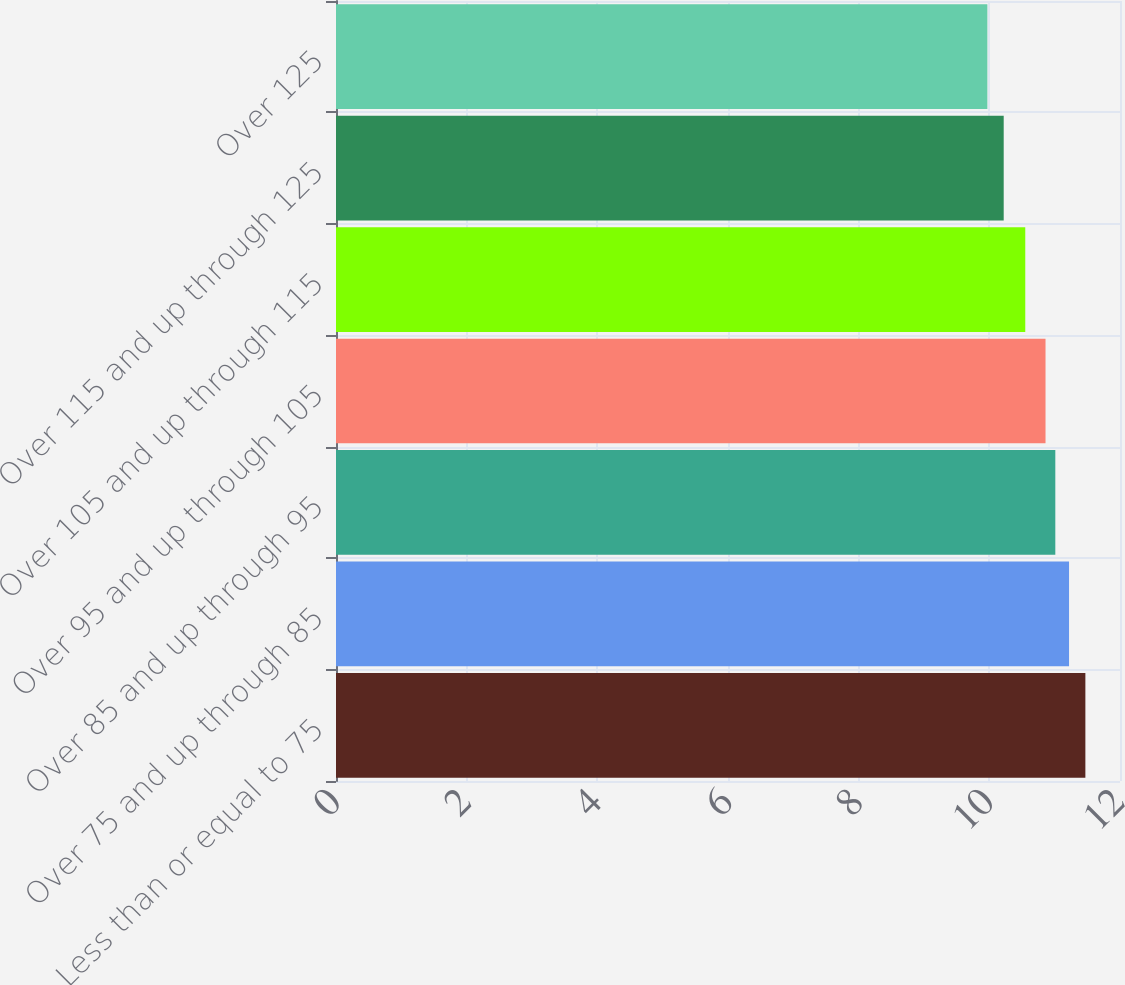<chart> <loc_0><loc_0><loc_500><loc_500><bar_chart><fcel>Less than or equal to 75<fcel>Over 75 and up through 85<fcel>Over 85 and up through 95<fcel>Over 95 and up through 105<fcel>Over 105 and up through 115<fcel>Over 115 and up through 125<fcel>Over 125<nl><fcel>11.47<fcel>11.22<fcel>11.01<fcel>10.86<fcel>10.55<fcel>10.22<fcel>9.97<nl></chart> 